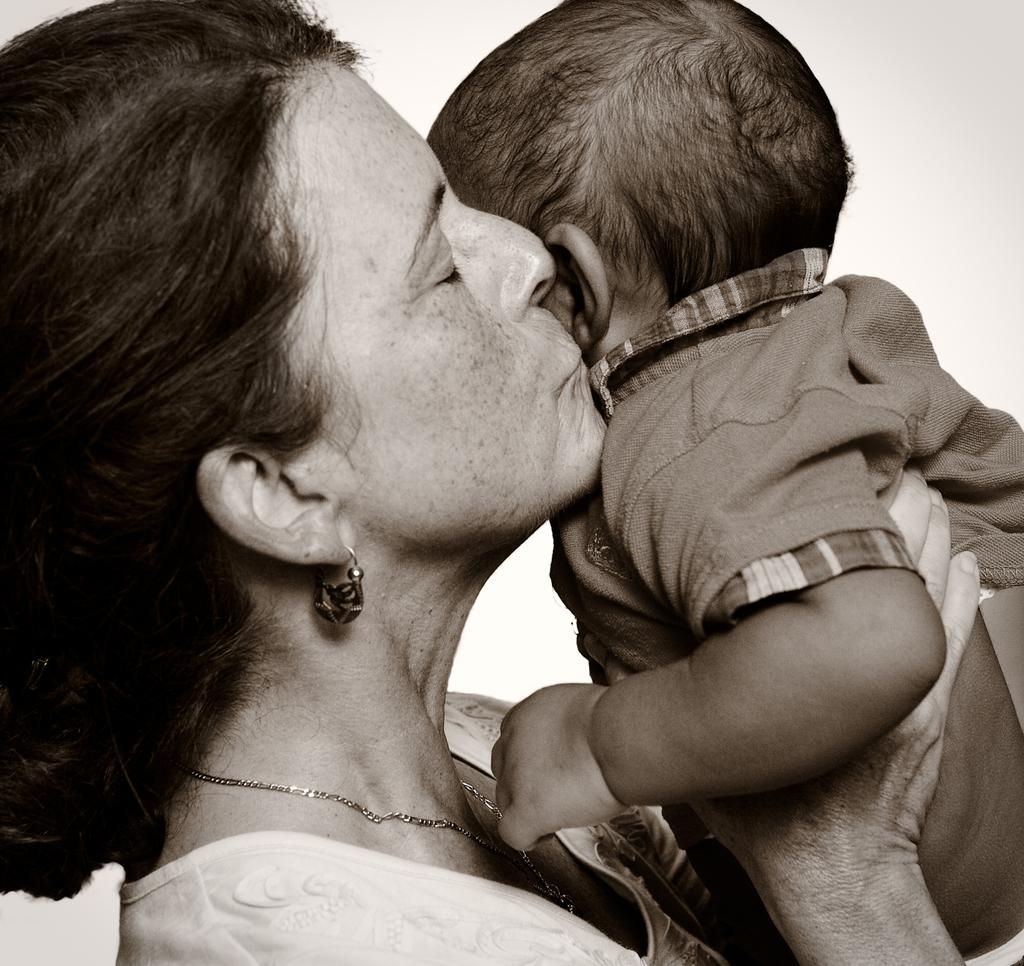Who is the main subject in the image? There is a woman in the image. What is the woman doing in the image? The woman is kissing a baby and holding the baby. What can be seen in the background of the image? The background of the image is white. What type of farm animals can be seen in the image? There are no farm animals present in the image. Is there a judge in the image? There is no judge present in the image. 